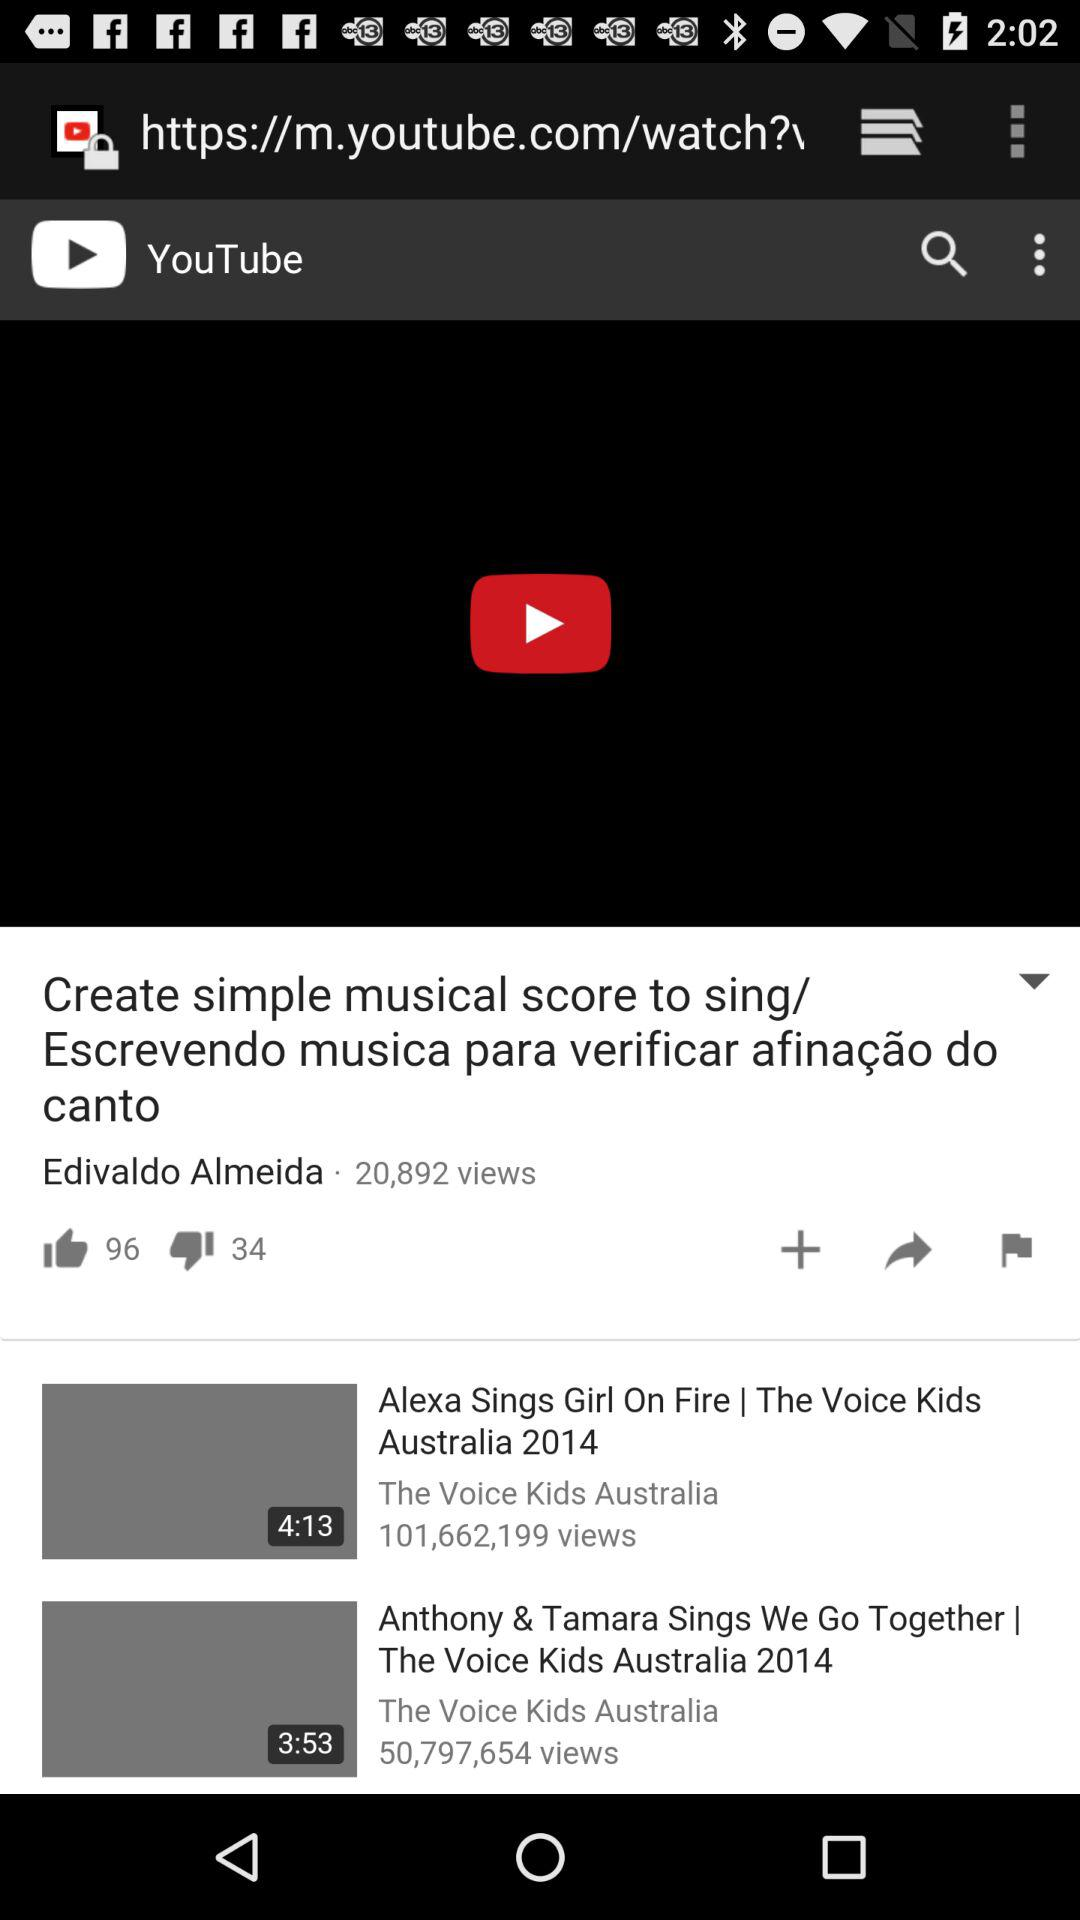How many dislikes are there on the "Create simple musical score to sing/ Escrevendo musica para verificar afinação do canto" video? There are 34 dislikes on the "Create simple musical score to sing/ Escrevendo musica para verificar afinação do canto" video. 